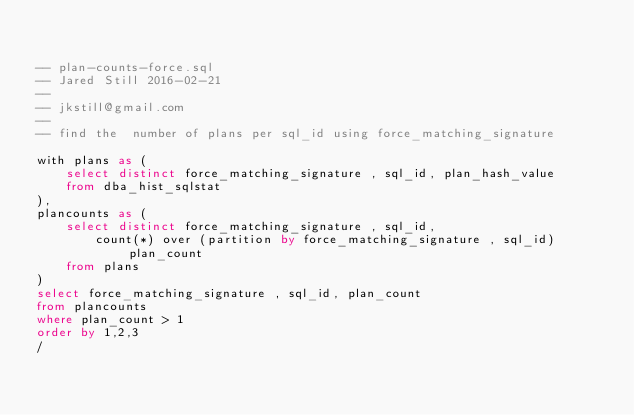Convert code to text. <code><loc_0><loc_0><loc_500><loc_500><_SQL_>

-- plan-counts-force.sql
-- Jared Still 2016-02-21
-- 
-- jkstill@gmail.com
-- 
-- find the  number of plans per sql_id using force_matching_signature

with plans as (
	select distinct force_matching_signature , sql_id, plan_hash_value
	from dba_hist_sqlstat
),
plancounts as (
	select distinct force_matching_signature , sql_id,
		count(*) over (partition by force_matching_signature , sql_id) plan_count
	from plans
)
select force_matching_signature , sql_id, plan_count
from plancounts
where plan_count > 1
order by 1,2,3
/
</code> 